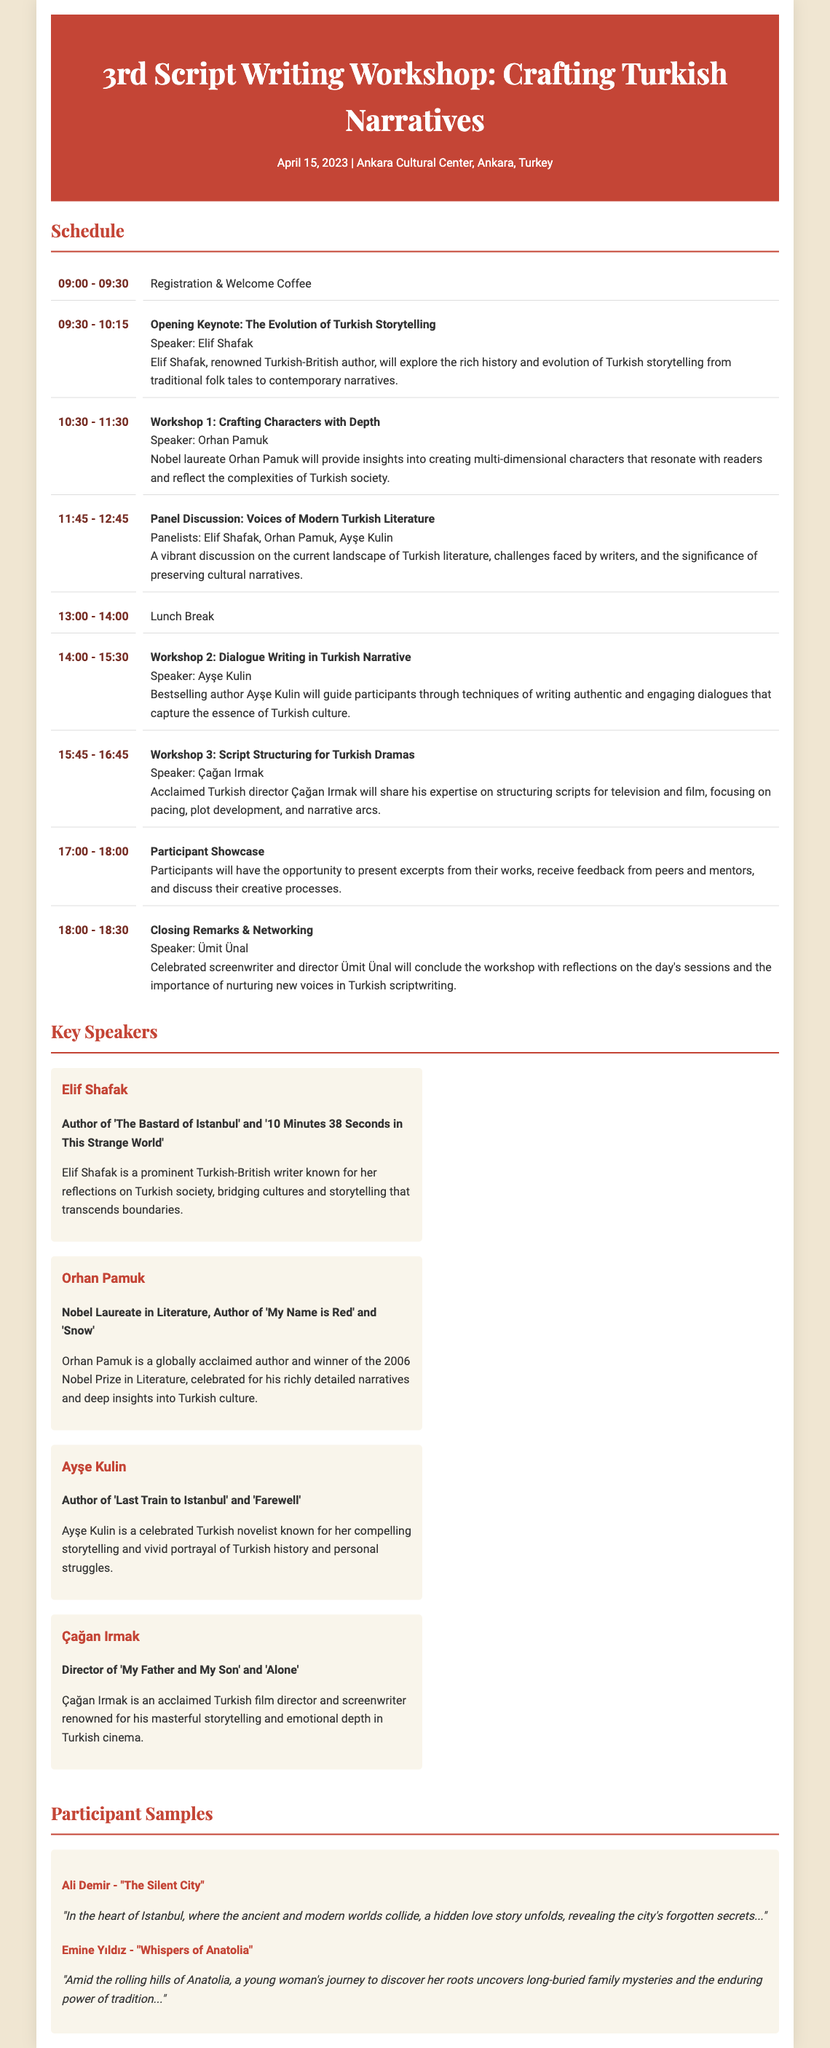What is the date of the workshop? The date of the workshop is mentioned at the top of the document.
Answer: April 15, 2023 Who is the opening keynote speaker? The document specifies Elif Shafak as the opening keynote speaker.
Answer: Elif Shafak What is the title of Workshop 2? The title of Workshop 2 is listed in the schedule section of the document.
Answer: Dialogue Writing in Turkish Narrative How many speakers are featured in the event? The document provides a list of key speakers under the "Key Speakers" section.
Answer: Four Which speaker is a Nobel Laureate? The document identifies Orhan Pamuk as a Nobel Laureate in the speakers section.
Answer: Orhan Pamuk What time does the participant showcase start? The schedule states the starting time for the participant showcase clearly.
Answer: 17:00 What is the primary focus of the closing remarks? The closing remarks will reflect on the day's sessions and the importance of nurturing new voices in Turkish scriptwriting.
Answer: Nurturing new voices Which participant's work involves a hidden love story? The participant sample mentions Ali Demir's work with a hidden love story theme.
Answer: Ali Demir What type of workshop is led by Çağan Irmak? The document states the type of workshop by mentioning the focus in the workshop description.
Answer: Script Structuring for Turkish Dramas 